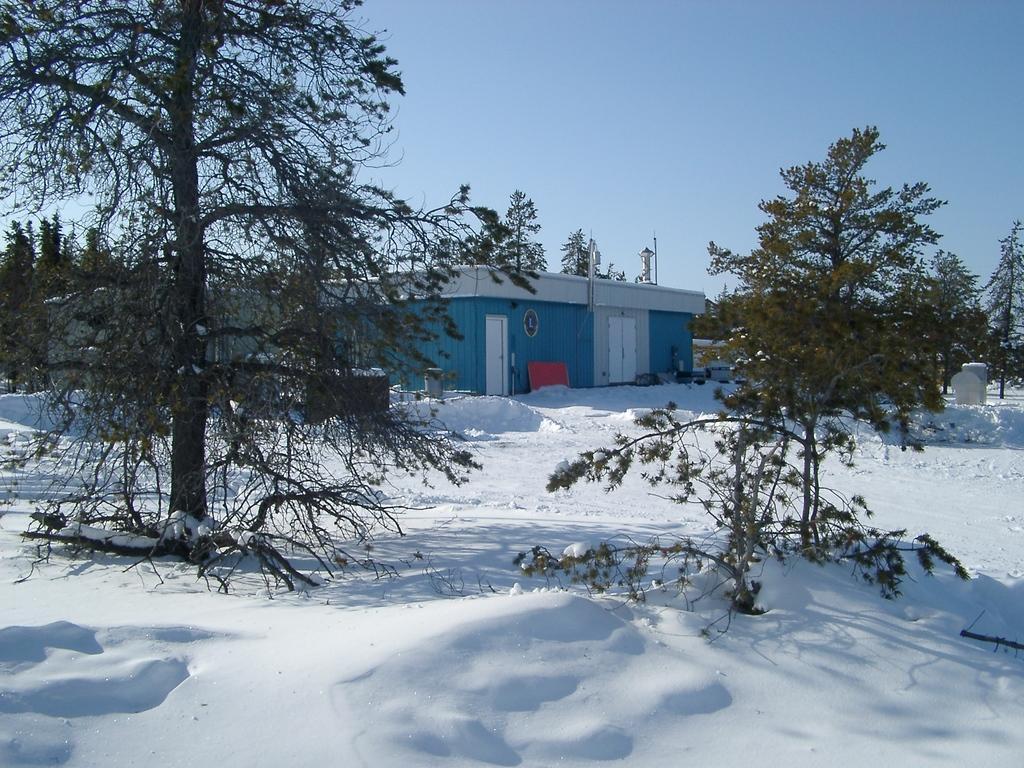In one or two sentences, can you explain what this image depicts? In this image we can see a group of trees, building. In the background, we can see the sky. 